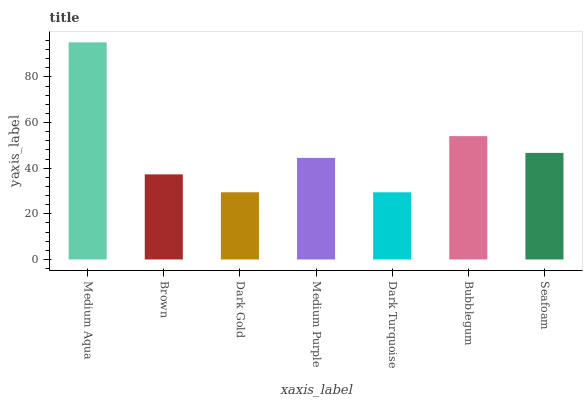Is Dark Turquoise the minimum?
Answer yes or no. Yes. Is Medium Aqua the maximum?
Answer yes or no. Yes. Is Brown the minimum?
Answer yes or no. No. Is Brown the maximum?
Answer yes or no. No. Is Medium Aqua greater than Brown?
Answer yes or no. Yes. Is Brown less than Medium Aqua?
Answer yes or no. Yes. Is Brown greater than Medium Aqua?
Answer yes or no. No. Is Medium Aqua less than Brown?
Answer yes or no. No. Is Medium Purple the high median?
Answer yes or no. Yes. Is Medium Purple the low median?
Answer yes or no. Yes. Is Dark Gold the high median?
Answer yes or no. No. Is Seafoam the low median?
Answer yes or no. No. 